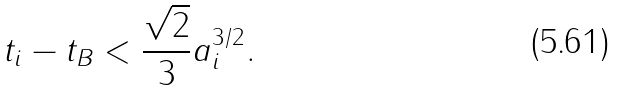Convert formula to latex. <formula><loc_0><loc_0><loc_500><loc_500>t _ { i } - t _ { B } < \frac { \sqrt { 2 } } { 3 } a _ { i } ^ { 3 / 2 } .</formula> 